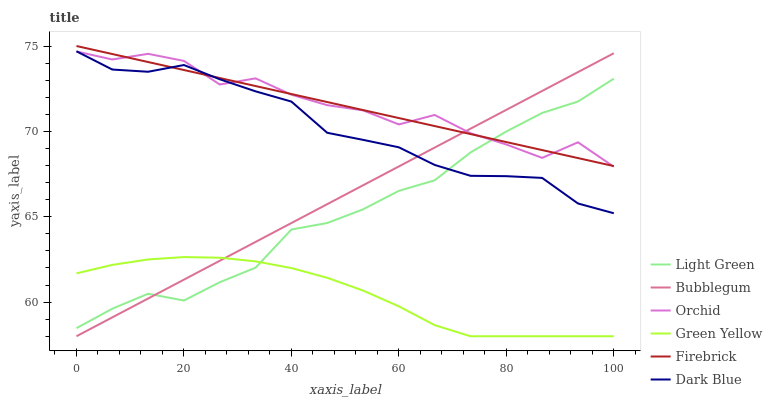Does Green Yellow have the minimum area under the curve?
Answer yes or no. Yes. Does Orchid have the maximum area under the curve?
Answer yes or no. Yes. Does Bubblegum have the minimum area under the curve?
Answer yes or no. No. Does Bubblegum have the maximum area under the curve?
Answer yes or no. No. Is Bubblegum the smoothest?
Answer yes or no. Yes. Is Orchid the roughest?
Answer yes or no. Yes. Is Dark Blue the smoothest?
Answer yes or no. No. Is Dark Blue the roughest?
Answer yes or no. No. Does Bubblegum have the lowest value?
Answer yes or no. Yes. Does Dark Blue have the lowest value?
Answer yes or no. No. Does Firebrick have the highest value?
Answer yes or no. Yes. Does Bubblegum have the highest value?
Answer yes or no. No. Is Green Yellow less than Dark Blue?
Answer yes or no. Yes. Is Dark Blue greater than Green Yellow?
Answer yes or no. Yes. Does Dark Blue intersect Orchid?
Answer yes or no. Yes. Is Dark Blue less than Orchid?
Answer yes or no. No. Is Dark Blue greater than Orchid?
Answer yes or no. No. Does Green Yellow intersect Dark Blue?
Answer yes or no. No. 